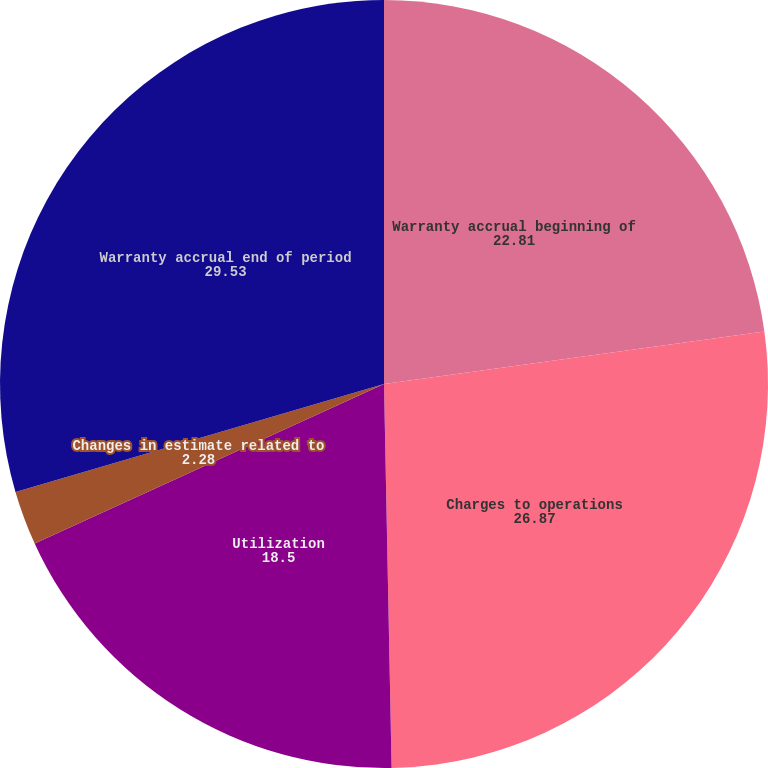Convert chart. <chart><loc_0><loc_0><loc_500><loc_500><pie_chart><fcel>Warranty accrual beginning of<fcel>Charges to operations<fcel>Utilization<fcel>Changes in estimate related to<fcel>Warranty accrual end of period<nl><fcel>22.81%<fcel>26.87%<fcel>18.5%<fcel>2.28%<fcel>29.53%<nl></chart> 